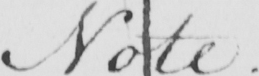Transcribe the text shown in this historical manuscript line. Note . 